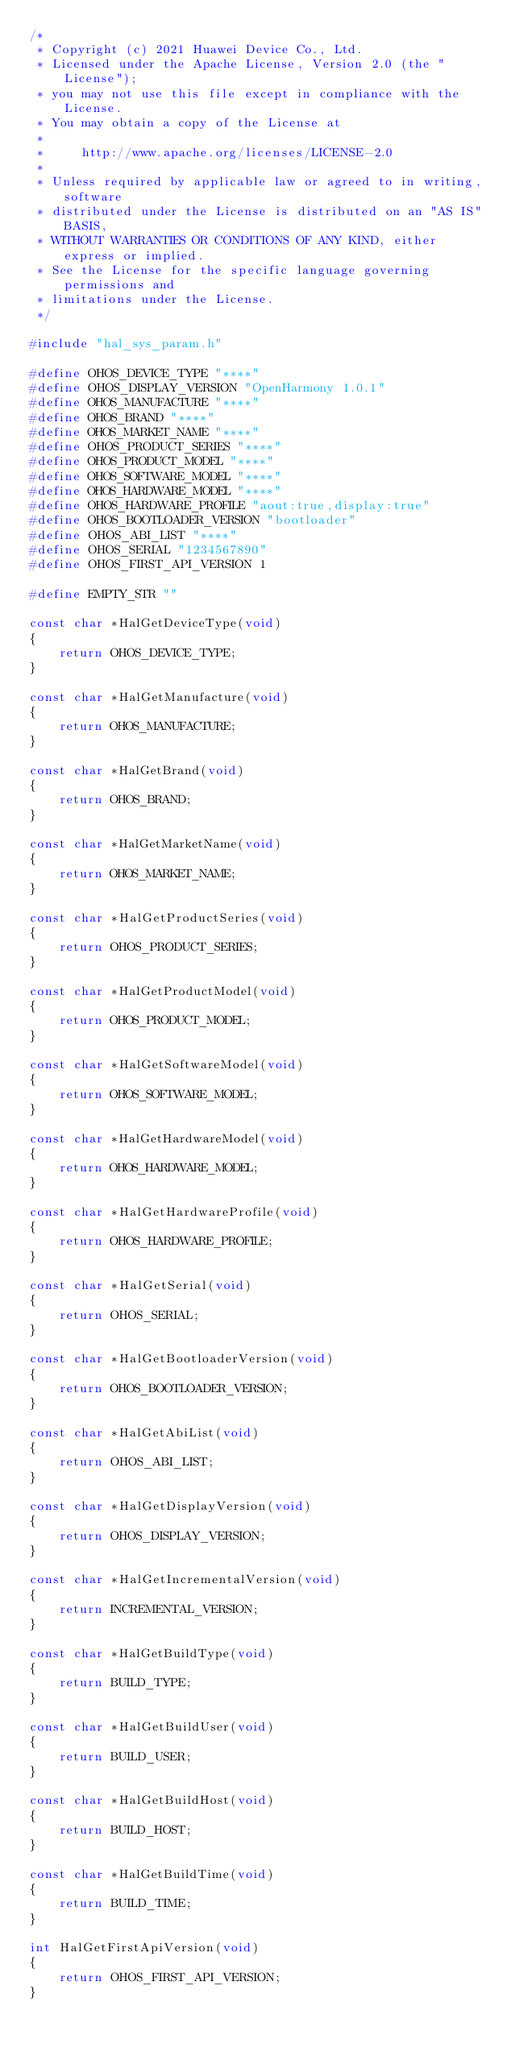<code> <loc_0><loc_0><loc_500><loc_500><_C_>/*
 * Copyright (c) 2021 Huawei Device Co., Ltd.
 * Licensed under the Apache License, Version 2.0 (the "License");
 * you may not use this file except in compliance with the License.
 * You may obtain a copy of the License at
 *
 *     http://www.apache.org/licenses/LICENSE-2.0
 *
 * Unless required by applicable law or agreed to in writing, software
 * distributed under the License is distributed on an "AS IS" BASIS,
 * WITHOUT WARRANTIES OR CONDITIONS OF ANY KIND, either express or implied.
 * See the License for the specific language governing permissions and
 * limitations under the License.
 */

#include "hal_sys_param.h"

#define OHOS_DEVICE_TYPE "****"
#define OHOS_DISPLAY_VERSION "OpenHarmony 1.0.1"
#define OHOS_MANUFACTURE "****"
#define OHOS_BRAND "****"
#define OHOS_MARKET_NAME "****"
#define OHOS_PRODUCT_SERIES "****"
#define OHOS_PRODUCT_MODEL "****"
#define OHOS_SOFTWARE_MODEL "****"
#define OHOS_HARDWARE_MODEL "****"
#define OHOS_HARDWARE_PROFILE "aout:true,display:true"
#define OHOS_BOOTLOADER_VERSION "bootloader"
#define OHOS_ABI_LIST "****"
#define OHOS_SERIAL "1234567890"
#define OHOS_FIRST_API_VERSION 1

#define EMPTY_STR ""

const char *HalGetDeviceType(void)
{
    return OHOS_DEVICE_TYPE;
}

const char *HalGetManufacture(void)
{
    return OHOS_MANUFACTURE;
}

const char *HalGetBrand(void)
{
    return OHOS_BRAND;
}

const char *HalGetMarketName(void)
{
    return OHOS_MARKET_NAME;
}

const char *HalGetProductSeries(void)
{
    return OHOS_PRODUCT_SERIES;
}

const char *HalGetProductModel(void)
{
    return OHOS_PRODUCT_MODEL;
}

const char *HalGetSoftwareModel(void)
{
    return OHOS_SOFTWARE_MODEL;
}

const char *HalGetHardwareModel(void)
{
    return OHOS_HARDWARE_MODEL;
}

const char *HalGetHardwareProfile(void)
{
    return OHOS_HARDWARE_PROFILE;
}

const char *HalGetSerial(void)
{
    return OHOS_SERIAL;
}

const char *HalGetBootloaderVersion(void)
{
    return OHOS_BOOTLOADER_VERSION;
}

const char *HalGetAbiList(void)
{
    return OHOS_ABI_LIST;
}

const char *HalGetDisplayVersion(void)
{
    return OHOS_DISPLAY_VERSION;
}

const char *HalGetIncrementalVersion(void)
{
    return INCREMENTAL_VERSION;
}

const char *HalGetBuildType(void)
{
    return BUILD_TYPE;
}

const char *HalGetBuildUser(void)
{
    return BUILD_USER;
}

const char *HalGetBuildHost(void)
{
    return BUILD_HOST;
}

const char *HalGetBuildTime(void)
{
    return BUILD_TIME;
}

int HalGetFirstApiVersion(void)
{
    return OHOS_FIRST_API_VERSION;
}
</code> 